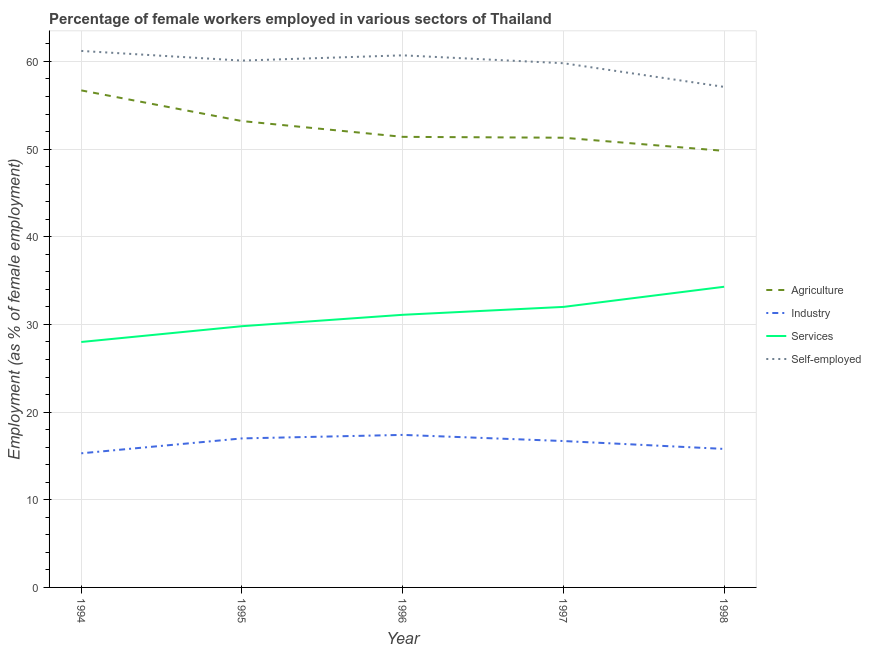Does the line corresponding to percentage of female workers in services intersect with the line corresponding to percentage of female workers in agriculture?
Provide a succinct answer. No. Is the number of lines equal to the number of legend labels?
Offer a terse response. Yes. What is the percentage of female workers in agriculture in 1994?
Provide a succinct answer. 56.7. Across all years, what is the maximum percentage of female workers in agriculture?
Offer a terse response. 56.7. Across all years, what is the minimum percentage of female workers in services?
Ensure brevity in your answer.  28. In which year was the percentage of self employed female workers minimum?
Keep it short and to the point. 1998. What is the total percentage of female workers in agriculture in the graph?
Keep it short and to the point. 262.4. What is the difference between the percentage of female workers in agriculture in 1994 and that in 1998?
Keep it short and to the point. 6.9. What is the difference between the percentage of female workers in agriculture in 1997 and the percentage of female workers in services in 1994?
Your answer should be very brief. 23.3. What is the average percentage of female workers in industry per year?
Ensure brevity in your answer.  16.44. In the year 1995, what is the difference between the percentage of female workers in agriculture and percentage of self employed female workers?
Make the answer very short. -6.9. In how many years, is the percentage of female workers in industry greater than 56 %?
Your answer should be very brief. 0. What is the ratio of the percentage of self employed female workers in 1994 to that in 1997?
Ensure brevity in your answer.  1.02. Is the percentage of female workers in services in 1996 less than that in 1997?
Offer a terse response. Yes. What is the difference between the highest and the second highest percentage of female workers in agriculture?
Provide a short and direct response. 3.5. What is the difference between the highest and the lowest percentage of female workers in services?
Offer a terse response. 6.3. Is it the case that in every year, the sum of the percentage of female workers in agriculture and percentage of female workers in services is greater than the sum of percentage of self employed female workers and percentage of female workers in industry?
Make the answer very short. No. Does the percentage of female workers in services monotonically increase over the years?
Provide a short and direct response. Yes. Is the percentage of female workers in agriculture strictly less than the percentage of self employed female workers over the years?
Make the answer very short. Yes. How many lines are there?
Give a very brief answer. 4. What is the difference between two consecutive major ticks on the Y-axis?
Offer a terse response. 10. Are the values on the major ticks of Y-axis written in scientific E-notation?
Your response must be concise. No. Does the graph contain any zero values?
Your answer should be very brief. No. Where does the legend appear in the graph?
Make the answer very short. Center right. How many legend labels are there?
Offer a very short reply. 4. What is the title of the graph?
Your answer should be compact. Percentage of female workers employed in various sectors of Thailand. Does "Budget management" appear as one of the legend labels in the graph?
Make the answer very short. No. What is the label or title of the Y-axis?
Your response must be concise. Employment (as % of female employment). What is the Employment (as % of female employment) in Agriculture in 1994?
Keep it short and to the point. 56.7. What is the Employment (as % of female employment) of Industry in 1994?
Provide a succinct answer. 15.3. What is the Employment (as % of female employment) of Services in 1994?
Give a very brief answer. 28. What is the Employment (as % of female employment) in Self-employed in 1994?
Offer a very short reply. 61.2. What is the Employment (as % of female employment) in Agriculture in 1995?
Provide a succinct answer. 53.2. What is the Employment (as % of female employment) of Industry in 1995?
Offer a terse response. 17. What is the Employment (as % of female employment) of Services in 1995?
Make the answer very short. 29.8. What is the Employment (as % of female employment) in Self-employed in 1995?
Your answer should be very brief. 60.1. What is the Employment (as % of female employment) in Agriculture in 1996?
Provide a short and direct response. 51.4. What is the Employment (as % of female employment) in Industry in 1996?
Your answer should be very brief. 17.4. What is the Employment (as % of female employment) in Services in 1996?
Give a very brief answer. 31.1. What is the Employment (as % of female employment) in Self-employed in 1996?
Your response must be concise. 60.7. What is the Employment (as % of female employment) in Agriculture in 1997?
Your answer should be compact. 51.3. What is the Employment (as % of female employment) of Industry in 1997?
Make the answer very short. 16.7. What is the Employment (as % of female employment) of Services in 1997?
Your answer should be very brief. 32. What is the Employment (as % of female employment) of Self-employed in 1997?
Ensure brevity in your answer.  59.8. What is the Employment (as % of female employment) of Agriculture in 1998?
Ensure brevity in your answer.  49.8. What is the Employment (as % of female employment) of Industry in 1998?
Your answer should be compact. 15.8. What is the Employment (as % of female employment) in Services in 1998?
Provide a short and direct response. 34.3. What is the Employment (as % of female employment) of Self-employed in 1998?
Give a very brief answer. 57.1. Across all years, what is the maximum Employment (as % of female employment) of Agriculture?
Give a very brief answer. 56.7. Across all years, what is the maximum Employment (as % of female employment) in Industry?
Provide a short and direct response. 17.4. Across all years, what is the maximum Employment (as % of female employment) of Services?
Provide a short and direct response. 34.3. Across all years, what is the maximum Employment (as % of female employment) in Self-employed?
Offer a terse response. 61.2. Across all years, what is the minimum Employment (as % of female employment) in Agriculture?
Ensure brevity in your answer.  49.8. Across all years, what is the minimum Employment (as % of female employment) in Industry?
Provide a succinct answer. 15.3. Across all years, what is the minimum Employment (as % of female employment) of Services?
Your answer should be compact. 28. Across all years, what is the minimum Employment (as % of female employment) of Self-employed?
Your response must be concise. 57.1. What is the total Employment (as % of female employment) in Agriculture in the graph?
Offer a terse response. 262.4. What is the total Employment (as % of female employment) of Industry in the graph?
Ensure brevity in your answer.  82.2. What is the total Employment (as % of female employment) in Services in the graph?
Offer a terse response. 155.2. What is the total Employment (as % of female employment) in Self-employed in the graph?
Provide a succinct answer. 298.9. What is the difference between the Employment (as % of female employment) in Agriculture in 1994 and that in 1995?
Provide a succinct answer. 3.5. What is the difference between the Employment (as % of female employment) in Services in 1994 and that in 1995?
Offer a terse response. -1.8. What is the difference between the Employment (as % of female employment) of Self-employed in 1994 and that in 1995?
Offer a terse response. 1.1. What is the difference between the Employment (as % of female employment) in Industry in 1994 and that in 1996?
Make the answer very short. -2.1. What is the difference between the Employment (as % of female employment) of Services in 1994 and that in 1996?
Give a very brief answer. -3.1. What is the difference between the Employment (as % of female employment) of Self-employed in 1994 and that in 1996?
Keep it short and to the point. 0.5. What is the difference between the Employment (as % of female employment) in Industry in 1994 and that in 1998?
Provide a succinct answer. -0.5. What is the difference between the Employment (as % of female employment) in Self-employed in 1994 and that in 1998?
Ensure brevity in your answer.  4.1. What is the difference between the Employment (as % of female employment) of Services in 1995 and that in 1996?
Ensure brevity in your answer.  -1.3. What is the difference between the Employment (as % of female employment) in Self-employed in 1995 and that in 1996?
Provide a succinct answer. -0.6. What is the difference between the Employment (as % of female employment) in Industry in 1995 and that in 1997?
Offer a terse response. 0.3. What is the difference between the Employment (as % of female employment) of Self-employed in 1995 and that in 1997?
Your response must be concise. 0.3. What is the difference between the Employment (as % of female employment) of Agriculture in 1995 and that in 1998?
Your answer should be compact. 3.4. What is the difference between the Employment (as % of female employment) of Industry in 1995 and that in 1998?
Your response must be concise. 1.2. What is the difference between the Employment (as % of female employment) of Industry in 1996 and that in 1997?
Your response must be concise. 0.7. What is the difference between the Employment (as % of female employment) of Services in 1996 and that in 1997?
Ensure brevity in your answer.  -0.9. What is the difference between the Employment (as % of female employment) in Self-employed in 1996 and that in 1997?
Offer a very short reply. 0.9. What is the difference between the Employment (as % of female employment) in Agriculture in 1996 and that in 1998?
Give a very brief answer. 1.6. What is the difference between the Employment (as % of female employment) of Services in 1996 and that in 1998?
Provide a succinct answer. -3.2. What is the difference between the Employment (as % of female employment) in Self-employed in 1996 and that in 1998?
Offer a very short reply. 3.6. What is the difference between the Employment (as % of female employment) of Services in 1997 and that in 1998?
Make the answer very short. -2.3. What is the difference between the Employment (as % of female employment) of Self-employed in 1997 and that in 1998?
Give a very brief answer. 2.7. What is the difference between the Employment (as % of female employment) of Agriculture in 1994 and the Employment (as % of female employment) of Industry in 1995?
Your answer should be very brief. 39.7. What is the difference between the Employment (as % of female employment) of Agriculture in 1994 and the Employment (as % of female employment) of Services in 1995?
Your response must be concise. 26.9. What is the difference between the Employment (as % of female employment) of Agriculture in 1994 and the Employment (as % of female employment) of Self-employed in 1995?
Offer a terse response. -3.4. What is the difference between the Employment (as % of female employment) of Industry in 1994 and the Employment (as % of female employment) of Services in 1995?
Your response must be concise. -14.5. What is the difference between the Employment (as % of female employment) of Industry in 1994 and the Employment (as % of female employment) of Self-employed in 1995?
Give a very brief answer. -44.8. What is the difference between the Employment (as % of female employment) in Services in 1994 and the Employment (as % of female employment) in Self-employed in 1995?
Your answer should be very brief. -32.1. What is the difference between the Employment (as % of female employment) in Agriculture in 1994 and the Employment (as % of female employment) in Industry in 1996?
Offer a terse response. 39.3. What is the difference between the Employment (as % of female employment) in Agriculture in 1994 and the Employment (as % of female employment) in Services in 1996?
Give a very brief answer. 25.6. What is the difference between the Employment (as % of female employment) in Agriculture in 1994 and the Employment (as % of female employment) in Self-employed in 1996?
Give a very brief answer. -4. What is the difference between the Employment (as % of female employment) in Industry in 1994 and the Employment (as % of female employment) in Services in 1996?
Offer a very short reply. -15.8. What is the difference between the Employment (as % of female employment) of Industry in 1994 and the Employment (as % of female employment) of Self-employed in 1996?
Make the answer very short. -45.4. What is the difference between the Employment (as % of female employment) in Services in 1994 and the Employment (as % of female employment) in Self-employed in 1996?
Ensure brevity in your answer.  -32.7. What is the difference between the Employment (as % of female employment) of Agriculture in 1994 and the Employment (as % of female employment) of Industry in 1997?
Provide a short and direct response. 40. What is the difference between the Employment (as % of female employment) of Agriculture in 1994 and the Employment (as % of female employment) of Services in 1997?
Ensure brevity in your answer.  24.7. What is the difference between the Employment (as % of female employment) of Industry in 1994 and the Employment (as % of female employment) of Services in 1997?
Your answer should be very brief. -16.7. What is the difference between the Employment (as % of female employment) in Industry in 1994 and the Employment (as % of female employment) in Self-employed in 1997?
Ensure brevity in your answer.  -44.5. What is the difference between the Employment (as % of female employment) in Services in 1994 and the Employment (as % of female employment) in Self-employed in 1997?
Offer a very short reply. -31.8. What is the difference between the Employment (as % of female employment) in Agriculture in 1994 and the Employment (as % of female employment) in Industry in 1998?
Ensure brevity in your answer.  40.9. What is the difference between the Employment (as % of female employment) in Agriculture in 1994 and the Employment (as % of female employment) in Services in 1998?
Ensure brevity in your answer.  22.4. What is the difference between the Employment (as % of female employment) in Agriculture in 1994 and the Employment (as % of female employment) in Self-employed in 1998?
Provide a short and direct response. -0.4. What is the difference between the Employment (as % of female employment) of Industry in 1994 and the Employment (as % of female employment) of Services in 1998?
Offer a very short reply. -19. What is the difference between the Employment (as % of female employment) in Industry in 1994 and the Employment (as % of female employment) in Self-employed in 1998?
Keep it short and to the point. -41.8. What is the difference between the Employment (as % of female employment) in Services in 1994 and the Employment (as % of female employment) in Self-employed in 1998?
Your answer should be compact. -29.1. What is the difference between the Employment (as % of female employment) in Agriculture in 1995 and the Employment (as % of female employment) in Industry in 1996?
Make the answer very short. 35.8. What is the difference between the Employment (as % of female employment) of Agriculture in 1995 and the Employment (as % of female employment) of Services in 1996?
Give a very brief answer. 22.1. What is the difference between the Employment (as % of female employment) of Industry in 1995 and the Employment (as % of female employment) of Services in 1996?
Offer a very short reply. -14.1. What is the difference between the Employment (as % of female employment) in Industry in 1995 and the Employment (as % of female employment) in Self-employed in 1996?
Ensure brevity in your answer.  -43.7. What is the difference between the Employment (as % of female employment) of Services in 1995 and the Employment (as % of female employment) of Self-employed in 1996?
Your response must be concise. -30.9. What is the difference between the Employment (as % of female employment) in Agriculture in 1995 and the Employment (as % of female employment) in Industry in 1997?
Offer a terse response. 36.5. What is the difference between the Employment (as % of female employment) in Agriculture in 1995 and the Employment (as % of female employment) in Services in 1997?
Give a very brief answer. 21.2. What is the difference between the Employment (as % of female employment) in Agriculture in 1995 and the Employment (as % of female employment) in Self-employed in 1997?
Make the answer very short. -6.6. What is the difference between the Employment (as % of female employment) in Industry in 1995 and the Employment (as % of female employment) in Self-employed in 1997?
Your answer should be compact. -42.8. What is the difference between the Employment (as % of female employment) in Agriculture in 1995 and the Employment (as % of female employment) in Industry in 1998?
Give a very brief answer. 37.4. What is the difference between the Employment (as % of female employment) of Agriculture in 1995 and the Employment (as % of female employment) of Services in 1998?
Your answer should be very brief. 18.9. What is the difference between the Employment (as % of female employment) of Industry in 1995 and the Employment (as % of female employment) of Services in 1998?
Your answer should be very brief. -17.3. What is the difference between the Employment (as % of female employment) of Industry in 1995 and the Employment (as % of female employment) of Self-employed in 1998?
Your answer should be compact. -40.1. What is the difference between the Employment (as % of female employment) in Services in 1995 and the Employment (as % of female employment) in Self-employed in 1998?
Keep it short and to the point. -27.3. What is the difference between the Employment (as % of female employment) of Agriculture in 1996 and the Employment (as % of female employment) of Industry in 1997?
Provide a short and direct response. 34.7. What is the difference between the Employment (as % of female employment) in Industry in 1996 and the Employment (as % of female employment) in Services in 1997?
Offer a very short reply. -14.6. What is the difference between the Employment (as % of female employment) of Industry in 1996 and the Employment (as % of female employment) of Self-employed in 1997?
Provide a succinct answer. -42.4. What is the difference between the Employment (as % of female employment) of Services in 1996 and the Employment (as % of female employment) of Self-employed in 1997?
Offer a very short reply. -28.7. What is the difference between the Employment (as % of female employment) in Agriculture in 1996 and the Employment (as % of female employment) in Industry in 1998?
Provide a short and direct response. 35.6. What is the difference between the Employment (as % of female employment) of Agriculture in 1996 and the Employment (as % of female employment) of Services in 1998?
Ensure brevity in your answer.  17.1. What is the difference between the Employment (as % of female employment) in Industry in 1996 and the Employment (as % of female employment) in Services in 1998?
Provide a succinct answer. -16.9. What is the difference between the Employment (as % of female employment) in Industry in 1996 and the Employment (as % of female employment) in Self-employed in 1998?
Your answer should be very brief. -39.7. What is the difference between the Employment (as % of female employment) in Services in 1996 and the Employment (as % of female employment) in Self-employed in 1998?
Provide a short and direct response. -26. What is the difference between the Employment (as % of female employment) of Agriculture in 1997 and the Employment (as % of female employment) of Industry in 1998?
Offer a very short reply. 35.5. What is the difference between the Employment (as % of female employment) of Agriculture in 1997 and the Employment (as % of female employment) of Services in 1998?
Give a very brief answer. 17. What is the difference between the Employment (as % of female employment) of Agriculture in 1997 and the Employment (as % of female employment) of Self-employed in 1998?
Provide a succinct answer. -5.8. What is the difference between the Employment (as % of female employment) in Industry in 1997 and the Employment (as % of female employment) in Services in 1998?
Ensure brevity in your answer.  -17.6. What is the difference between the Employment (as % of female employment) in Industry in 1997 and the Employment (as % of female employment) in Self-employed in 1998?
Give a very brief answer. -40.4. What is the difference between the Employment (as % of female employment) of Services in 1997 and the Employment (as % of female employment) of Self-employed in 1998?
Make the answer very short. -25.1. What is the average Employment (as % of female employment) of Agriculture per year?
Your answer should be compact. 52.48. What is the average Employment (as % of female employment) of Industry per year?
Provide a short and direct response. 16.44. What is the average Employment (as % of female employment) of Services per year?
Offer a very short reply. 31.04. What is the average Employment (as % of female employment) of Self-employed per year?
Keep it short and to the point. 59.78. In the year 1994, what is the difference between the Employment (as % of female employment) of Agriculture and Employment (as % of female employment) of Industry?
Make the answer very short. 41.4. In the year 1994, what is the difference between the Employment (as % of female employment) in Agriculture and Employment (as % of female employment) in Services?
Your response must be concise. 28.7. In the year 1994, what is the difference between the Employment (as % of female employment) of Agriculture and Employment (as % of female employment) of Self-employed?
Provide a succinct answer. -4.5. In the year 1994, what is the difference between the Employment (as % of female employment) in Industry and Employment (as % of female employment) in Self-employed?
Your answer should be very brief. -45.9. In the year 1994, what is the difference between the Employment (as % of female employment) of Services and Employment (as % of female employment) of Self-employed?
Your answer should be very brief. -33.2. In the year 1995, what is the difference between the Employment (as % of female employment) in Agriculture and Employment (as % of female employment) in Industry?
Provide a short and direct response. 36.2. In the year 1995, what is the difference between the Employment (as % of female employment) of Agriculture and Employment (as % of female employment) of Services?
Keep it short and to the point. 23.4. In the year 1995, what is the difference between the Employment (as % of female employment) of Industry and Employment (as % of female employment) of Services?
Your answer should be very brief. -12.8. In the year 1995, what is the difference between the Employment (as % of female employment) in Industry and Employment (as % of female employment) in Self-employed?
Your answer should be compact. -43.1. In the year 1995, what is the difference between the Employment (as % of female employment) of Services and Employment (as % of female employment) of Self-employed?
Make the answer very short. -30.3. In the year 1996, what is the difference between the Employment (as % of female employment) in Agriculture and Employment (as % of female employment) in Industry?
Provide a succinct answer. 34. In the year 1996, what is the difference between the Employment (as % of female employment) of Agriculture and Employment (as % of female employment) of Services?
Keep it short and to the point. 20.3. In the year 1996, what is the difference between the Employment (as % of female employment) in Industry and Employment (as % of female employment) in Services?
Provide a short and direct response. -13.7. In the year 1996, what is the difference between the Employment (as % of female employment) in Industry and Employment (as % of female employment) in Self-employed?
Make the answer very short. -43.3. In the year 1996, what is the difference between the Employment (as % of female employment) in Services and Employment (as % of female employment) in Self-employed?
Your answer should be compact. -29.6. In the year 1997, what is the difference between the Employment (as % of female employment) of Agriculture and Employment (as % of female employment) of Industry?
Offer a terse response. 34.6. In the year 1997, what is the difference between the Employment (as % of female employment) of Agriculture and Employment (as % of female employment) of Services?
Give a very brief answer. 19.3. In the year 1997, what is the difference between the Employment (as % of female employment) in Industry and Employment (as % of female employment) in Services?
Offer a terse response. -15.3. In the year 1997, what is the difference between the Employment (as % of female employment) of Industry and Employment (as % of female employment) of Self-employed?
Your response must be concise. -43.1. In the year 1997, what is the difference between the Employment (as % of female employment) of Services and Employment (as % of female employment) of Self-employed?
Offer a terse response. -27.8. In the year 1998, what is the difference between the Employment (as % of female employment) in Agriculture and Employment (as % of female employment) in Services?
Your answer should be very brief. 15.5. In the year 1998, what is the difference between the Employment (as % of female employment) in Agriculture and Employment (as % of female employment) in Self-employed?
Make the answer very short. -7.3. In the year 1998, what is the difference between the Employment (as % of female employment) in Industry and Employment (as % of female employment) in Services?
Keep it short and to the point. -18.5. In the year 1998, what is the difference between the Employment (as % of female employment) in Industry and Employment (as % of female employment) in Self-employed?
Your answer should be compact. -41.3. In the year 1998, what is the difference between the Employment (as % of female employment) of Services and Employment (as % of female employment) of Self-employed?
Offer a terse response. -22.8. What is the ratio of the Employment (as % of female employment) of Agriculture in 1994 to that in 1995?
Provide a succinct answer. 1.07. What is the ratio of the Employment (as % of female employment) in Industry in 1994 to that in 1995?
Give a very brief answer. 0.9. What is the ratio of the Employment (as % of female employment) of Services in 1994 to that in 1995?
Offer a terse response. 0.94. What is the ratio of the Employment (as % of female employment) of Self-employed in 1994 to that in 1995?
Give a very brief answer. 1.02. What is the ratio of the Employment (as % of female employment) in Agriculture in 1994 to that in 1996?
Ensure brevity in your answer.  1.1. What is the ratio of the Employment (as % of female employment) in Industry in 1994 to that in 1996?
Provide a succinct answer. 0.88. What is the ratio of the Employment (as % of female employment) in Services in 1994 to that in 1996?
Your response must be concise. 0.9. What is the ratio of the Employment (as % of female employment) in Self-employed in 1994 to that in 1996?
Your answer should be compact. 1.01. What is the ratio of the Employment (as % of female employment) of Agriculture in 1994 to that in 1997?
Provide a short and direct response. 1.11. What is the ratio of the Employment (as % of female employment) of Industry in 1994 to that in 1997?
Your response must be concise. 0.92. What is the ratio of the Employment (as % of female employment) in Self-employed in 1994 to that in 1997?
Make the answer very short. 1.02. What is the ratio of the Employment (as % of female employment) of Agriculture in 1994 to that in 1998?
Offer a terse response. 1.14. What is the ratio of the Employment (as % of female employment) in Industry in 1994 to that in 1998?
Your response must be concise. 0.97. What is the ratio of the Employment (as % of female employment) of Services in 1994 to that in 1998?
Your answer should be very brief. 0.82. What is the ratio of the Employment (as % of female employment) of Self-employed in 1994 to that in 1998?
Offer a very short reply. 1.07. What is the ratio of the Employment (as % of female employment) in Agriculture in 1995 to that in 1996?
Give a very brief answer. 1.03. What is the ratio of the Employment (as % of female employment) of Services in 1995 to that in 1996?
Your response must be concise. 0.96. What is the ratio of the Employment (as % of female employment) in Industry in 1995 to that in 1997?
Your answer should be very brief. 1.02. What is the ratio of the Employment (as % of female employment) in Services in 1995 to that in 1997?
Provide a succinct answer. 0.93. What is the ratio of the Employment (as % of female employment) in Agriculture in 1995 to that in 1998?
Give a very brief answer. 1.07. What is the ratio of the Employment (as % of female employment) of Industry in 1995 to that in 1998?
Your answer should be compact. 1.08. What is the ratio of the Employment (as % of female employment) in Services in 1995 to that in 1998?
Offer a very short reply. 0.87. What is the ratio of the Employment (as % of female employment) in Self-employed in 1995 to that in 1998?
Offer a terse response. 1.05. What is the ratio of the Employment (as % of female employment) in Agriculture in 1996 to that in 1997?
Provide a short and direct response. 1. What is the ratio of the Employment (as % of female employment) in Industry in 1996 to that in 1997?
Your answer should be very brief. 1.04. What is the ratio of the Employment (as % of female employment) of Services in 1996 to that in 1997?
Keep it short and to the point. 0.97. What is the ratio of the Employment (as % of female employment) in Self-employed in 1996 to that in 1997?
Keep it short and to the point. 1.02. What is the ratio of the Employment (as % of female employment) in Agriculture in 1996 to that in 1998?
Your response must be concise. 1.03. What is the ratio of the Employment (as % of female employment) in Industry in 1996 to that in 1998?
Offer a terse response. 1.1. What is the ratio of the Employment (as % of female employment) in Services in 1996 to that in 1998?
Make the answer very short. 0.91. What is the ratio of the Employment (as % of female employment) in Self-employed in 1996 to that in 1998?
Offer a very short reply. 1.06. What is the ratio of the Employment (as % of female employment) in Agriculture in 1997 to that in 1998?
Ensure brevity in your answer.  1.03. What is the ratio of the Employment (as % of female employment) in Industry in 1997 to that in 1998?
Offer a terse response. 1.06. What is the ratio of the Employment (as % of female employment) in Services in 1997 to that in 1998?
Offer a terse response. 0.93. What is the ratio of the Employment (as % of female employment) of Self-employed in 1997 to that in 1998?
Your response must be concise. 1.05. What is the difference between the highest and the second highest Employment (as % of female employment) in Services?
Offer a very short reply. 2.3. What is the difference between the highest and the second highest Employment (as % of female employment) of Self-employed?
Provide a succinct answer. 0.5. What is the difference between the highest and the lowest Employment (as % of female employment) in Agriculture?
Offer a very short reply. 6.9. What is the difference between the highest and the lowest Employment (as % of female employment) of Industry?
Keep it short and to the point. 2.1. What is the difference between the highest and the lowest Employment (as % of female employment) of Services?
Offer a very short reply. 6.3. 